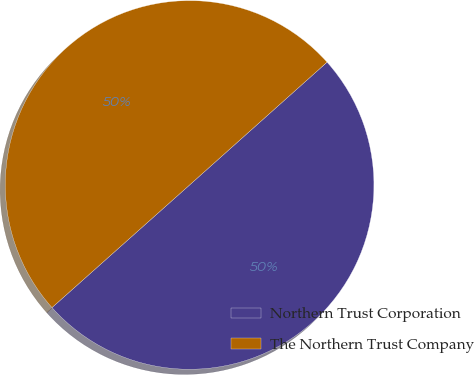Convert chart. <chart><loc_0><loc_0><loc_500><loc_500><pie_chart><fcel>Northern Trust Corporation<fcel>The Northern Trust Company<nl><fcel>50.02%<fcel>49.98%<nl></chart> 